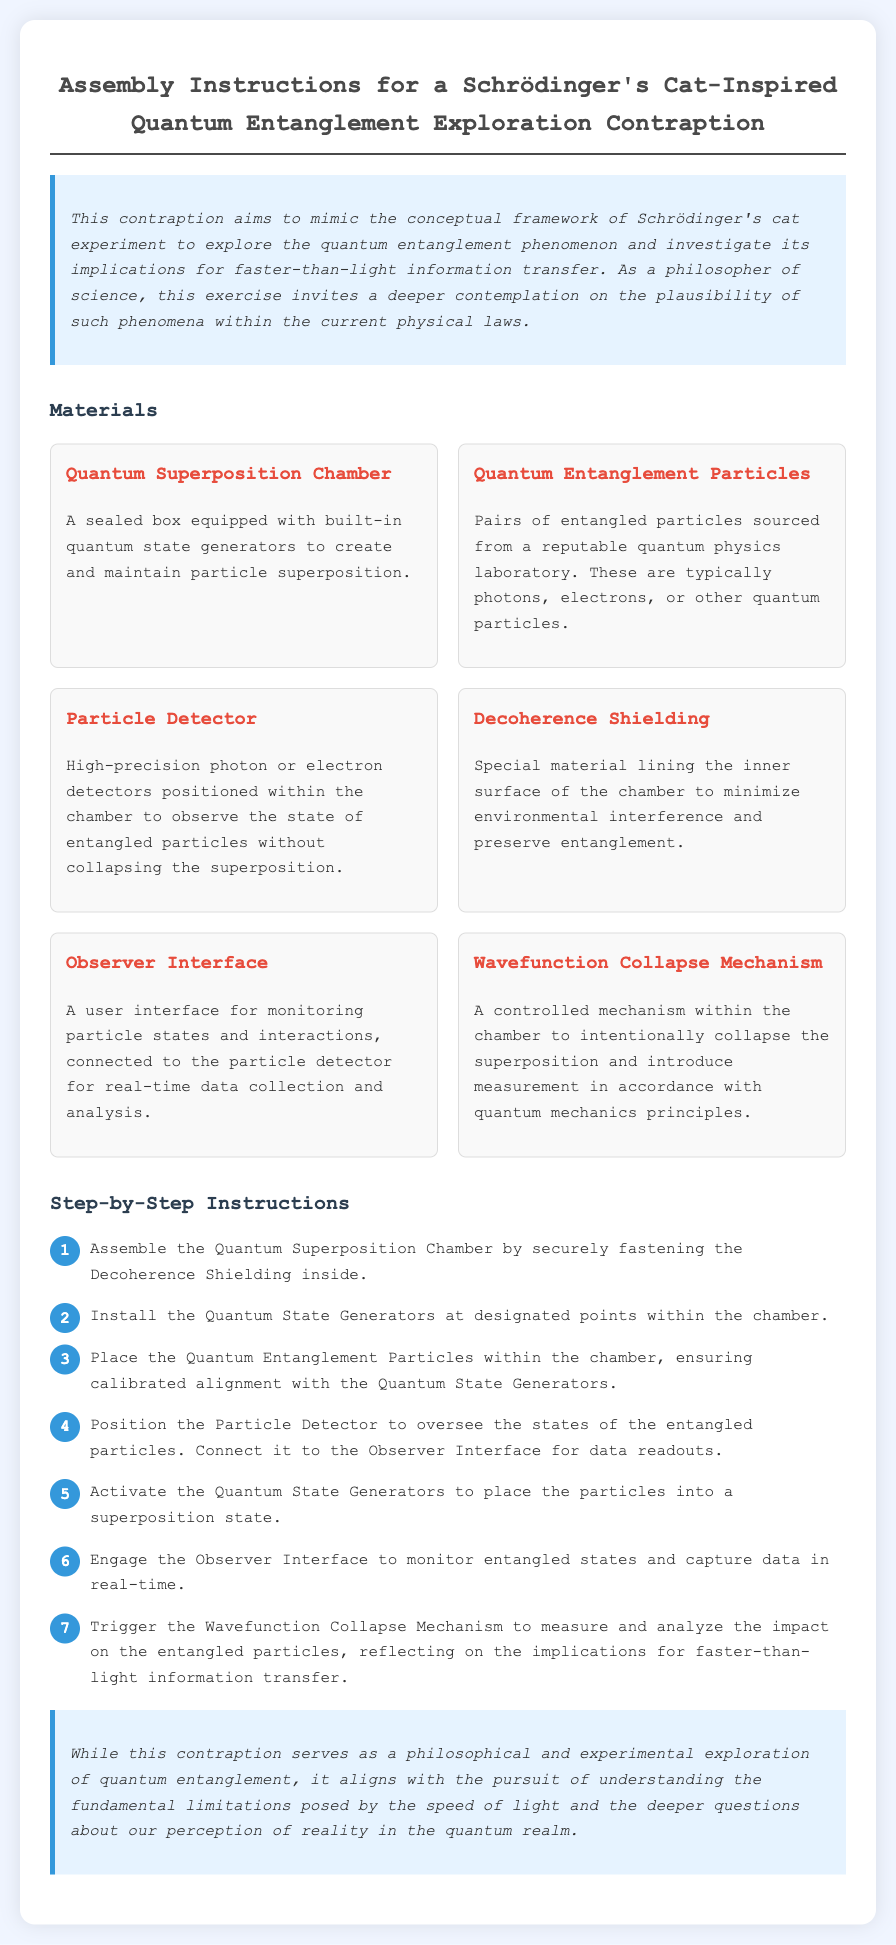What is the title of the document? The title is indicated at the top of the document, stating the subject of the assembly instructions.
Answer: Assembly Instructions for a Schrödinger's Cat-Inspired Quantum Entanglement Exploration Contraption How many materials are listed in the document? The number of materials is derived from the count of items in the materials section.
Answer: Six What is the function of the Decoherence Shielding? The role of the Decoherence Shielding is explained in the materials section, detailing its purpose in the assembly.
Answer: Minimize environmental interference What is the fifth step in the instructions? The fifth step can be found in the step-by-step instructions portion, noting the action to be taken at that stage.
Answer: Activate the Quantum State Generators to place the particles into a superposition state What mechanism is triggered to analyze entangled particles? The mechanism is explicitly mentioned in the last step of the assembly instructions, indicating what is engaged to observe particle behavior.
Answer: Wavefunction Collapse Mechanism What is the design motivation behind the contraption? The introductory section provides context for the experiment's philosophical and scientific intent.
Answer: Explore quantum entanglement What type of interface is used for monitoring? The document specifies the interface category used for monitoring interactions within the assembly as listed under materials.
Answer: Observer Interface 